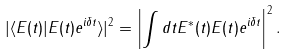Convert formula to latex. <formula><loc_0><loc_0><loc_500><loc_500>| \langle E ( t ) | E ( t ) e ^ { i \delta t } \rangle | ^ { 2 } = \left | \int d t E ^ { \ast } ( t ) E ( t ) e ^ { i \delta t } \right | ^ { 2 } .</formula> 